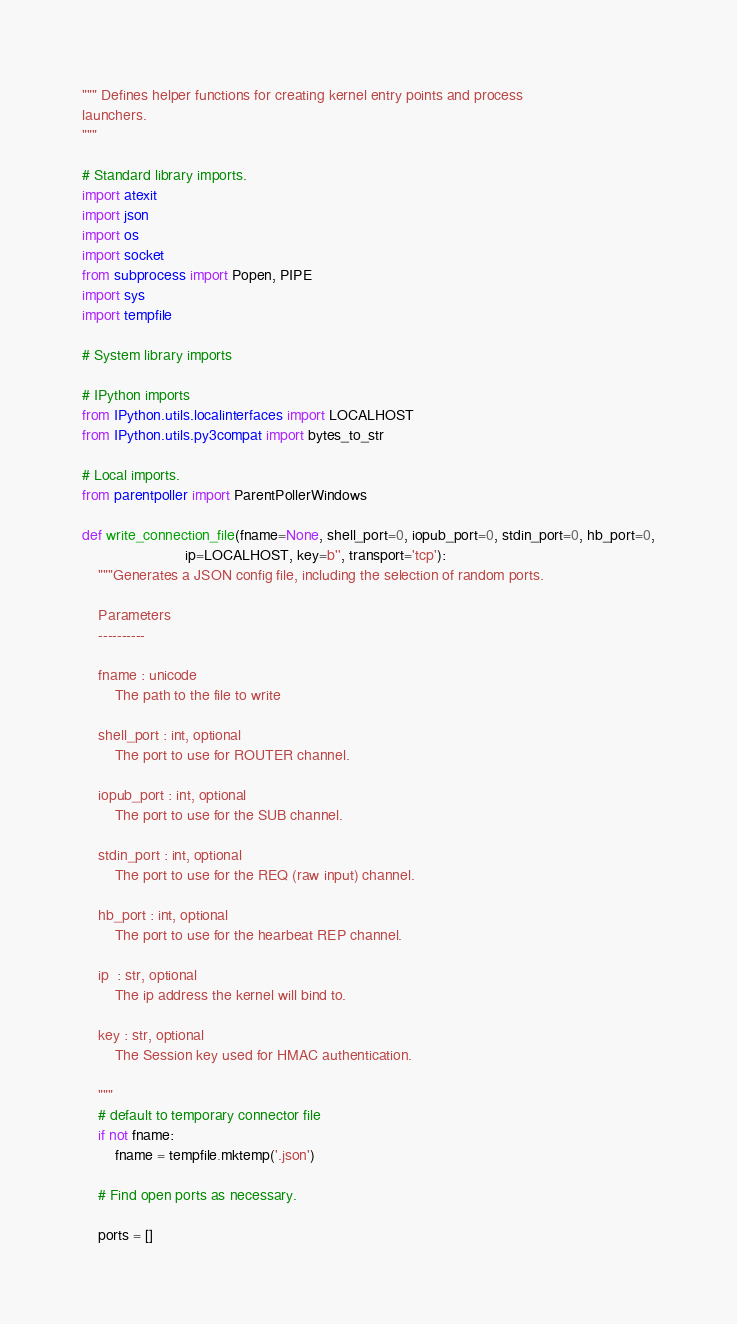Convert code to text. <code><loc_0><loc_0><loc_500><loc_500><_Python_>""" Defines helper functions for creating kernel entry points and process
launchers.
"""

# Standard library imports.
import atexit
import json
import os
import socket
from subprocess import Popen, PIPE
import sys
import tempfile

# System library imports

# IPython imports
from IPython.utils.localinterfaces import LOCALHOST
from IPython.utils.py3compat import bytes_to_str

# Local imports.
from parentpoller import ParentPollerWindows

def write_connection_file(fname=None, shell_port=0, iopub_port=0, stdin_port=0, hb_port=0,
                         ip=LOCALHOST, key=b'', transport='tcp'):
    """Generates a JSON config file, including the selection of random ports.
    
    Parameters
    ----------

    fname : unicode
        The path to the file to write

    shell_port : int, optional
        The port to use for ROUTER channel.

    iopub_port : int, optional
        The port to use for the SUB channel.

    stdin_port : int, optional
        The port to use for the REQ (raw input) channel.

    hb_port : int, optional
        The port to use for the hearbeat REP channel.

    ip  : str, optional
        The ip address the kernel will bind to.

    key : str, optional
        The Session key used for HMAC authentication.

    """
    # default to temporary connector file
    if not fname:
        fname = tempfile.mktemp('.json')
    
    # Find open ports as necessary.
    
    ports = []</code> 